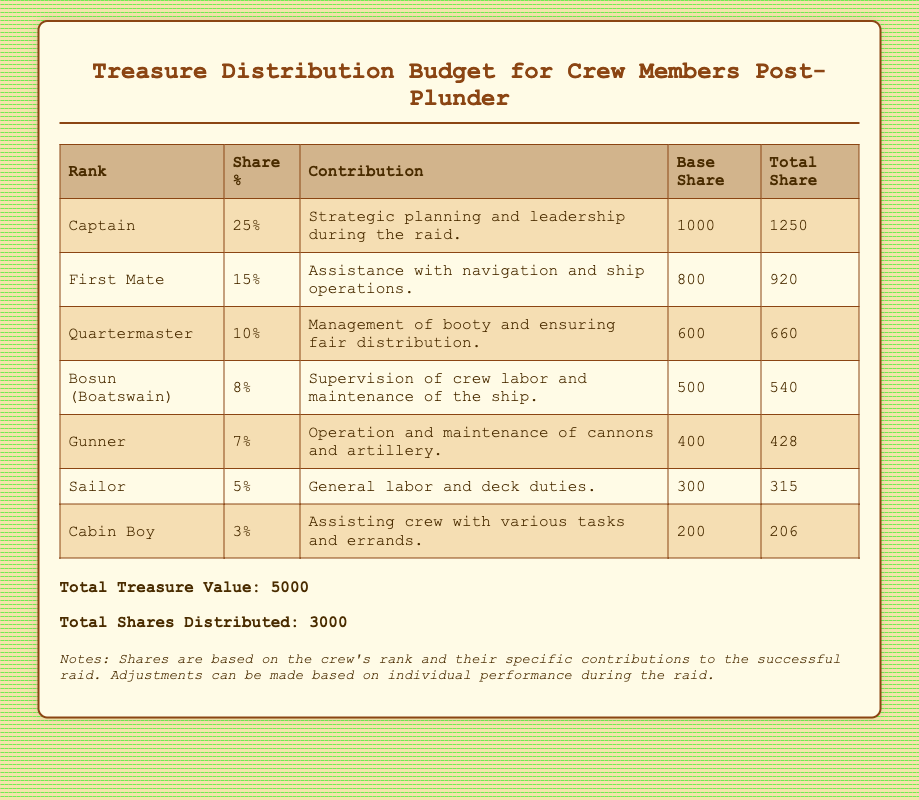What is the total treasure value? The total treasure value is listed at the end of the document as part of the summary.
Answer: 5000 What percentage share does the Captain receive? The Captain's share percentage is specified in the table under the "Share %" column.
Answer: 25% What is the contribution of the First Mate? The First Mate's contribution is detailed in the "Contribution" column next to their rank.
Answer: Assistance with navigation and ship operations How much total share does the Gunner get? The total share for the Gunner is found in the "Total Share" column for their rank.
Answer: 428 Which rank has the lowest share percentage? By examining the "Share %" column in the table, we can identify the rank with the lowest percentage.
Answer: Cabin Boy What is the base share allocated to the Bosun? The base share allocated is located in the "Base Share" column for the Bosun's rank.
Answer: 500 How many total shares were distributed? This information is provided in the summary section at the bottom of the document.
Answer: 3000 What role is responsible for managing the booty? The table specifies which rank has the responsibility of managing the booty in the "Contribution" column.
Answer: Quartermaster 